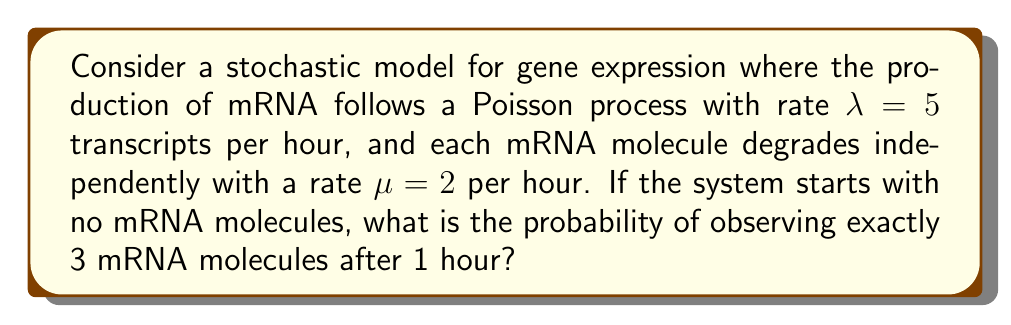Could you help me with this problem? To solve this problem, we can use the properties of the birth-death process, which is a type of continuous-time Markov chain often used in modeling gene expression.

1) In this case, we have a pure birth process (transcription) followed by death (degradation). The number of mRNA molecules at time $t$ follows a Poisson distribution with mean $\frac{\lambda}{\mu}(1-e^{-\mu t})$.

2) Let's calculate the mean number of mRNA molecules after 1 hour:

   $$\text{Mean} = \frac{\lambda}{\mu}(1-e^{-\mu t}) = \frac{5}{2}(1-e^{-2 \cdot 1}) \approx 2.0855$$

3) Now, we can use the Poisson probability mass function to calculate the probability of observing exactly 3 mRNA molecules:

   $$P(X = k) = \frac{e^{-\mu}\mu^k}{k!}$$

   where $\mu$ is the mean we calculated and $k = 3$

4) Plugging in our values:

   $$P(X = 3) = \frac{e^{-2.0855}(2.0855)^3}{3!}$$

5) Calculating this:

   $$P(X = 3) \approx 0.1847$$

Thus, the probability of observing exactly 3 mRNA molecules after 1 hour is approximately 0.1847 or 18.47%.
Answer: 0.1847 (or 18.47%) 